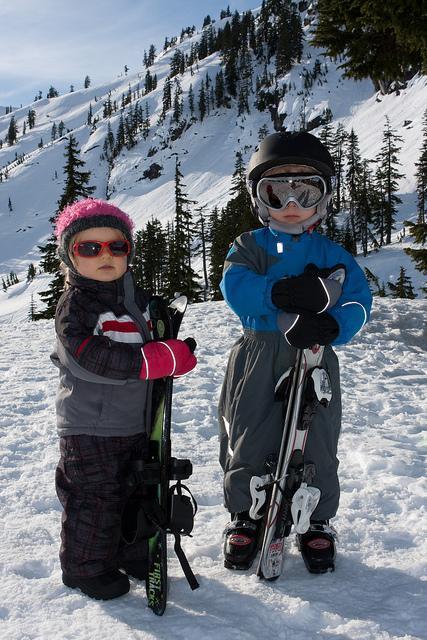How many people are there?
Give a very brief answer. 2. How many ski are there?
Give a very brief answer. 2. How many street signs with a horse in it?
Give a very brief answer. 0. 